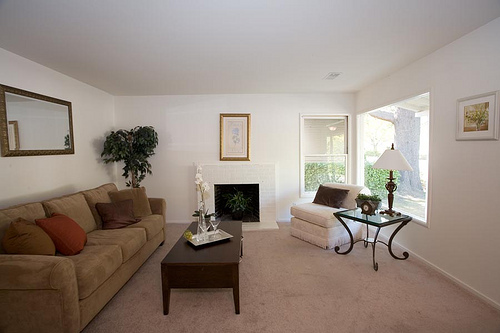<image>What kind of flowers are on the window sill? There are no flowers on the window sill. What kind of flowers are on the window sill? There are no flowers on the window sill. 